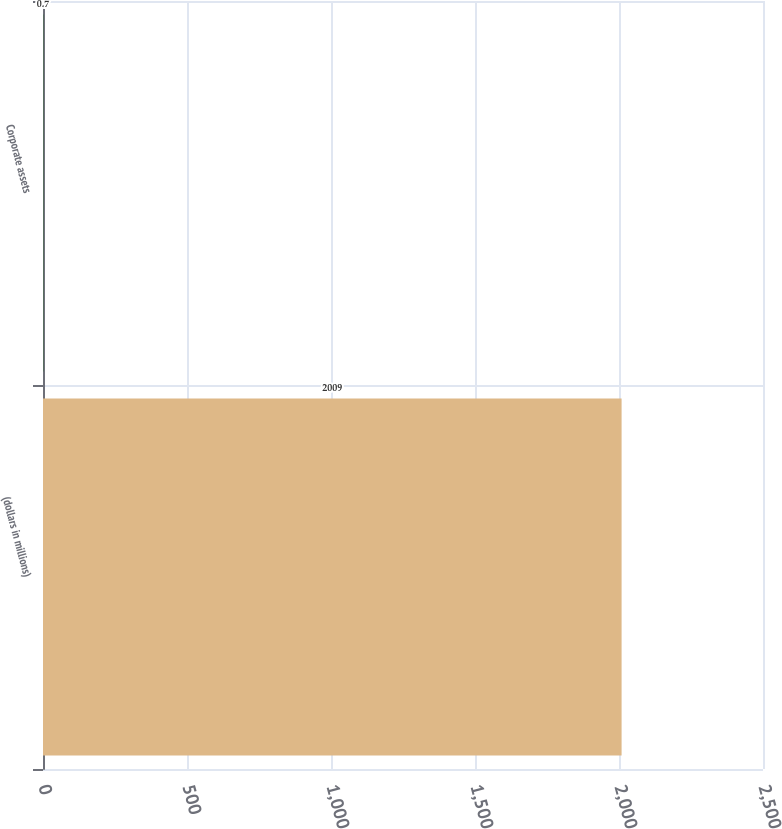Convert chart to OTSL. <chart><loc_0><loc_0><loc_500><loc_500><bar_chart><fcel>(dollars in millions)<fcel>Corporate assets<nl><fcel>2009<fcel>0.7<nl></chart> 